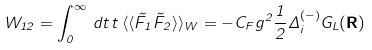Convert formula to latex. <formula><loc_0><loc_0><loc_500><loc_500>W _ { 1 2 } = \int _ { 0 } ^ { \infty } \, d t \, t \, \langle \langle \tilde { F } _ { 1 } \tilde { F } _ { 2 } \rangle \rangle _ { W } = - C _ { F } g ^ { 2 } \frac { 1 } { 2 } \Delta _ { i } ^ { ( - ) } G _ { L } ( { \mathbf R } )</formula> 